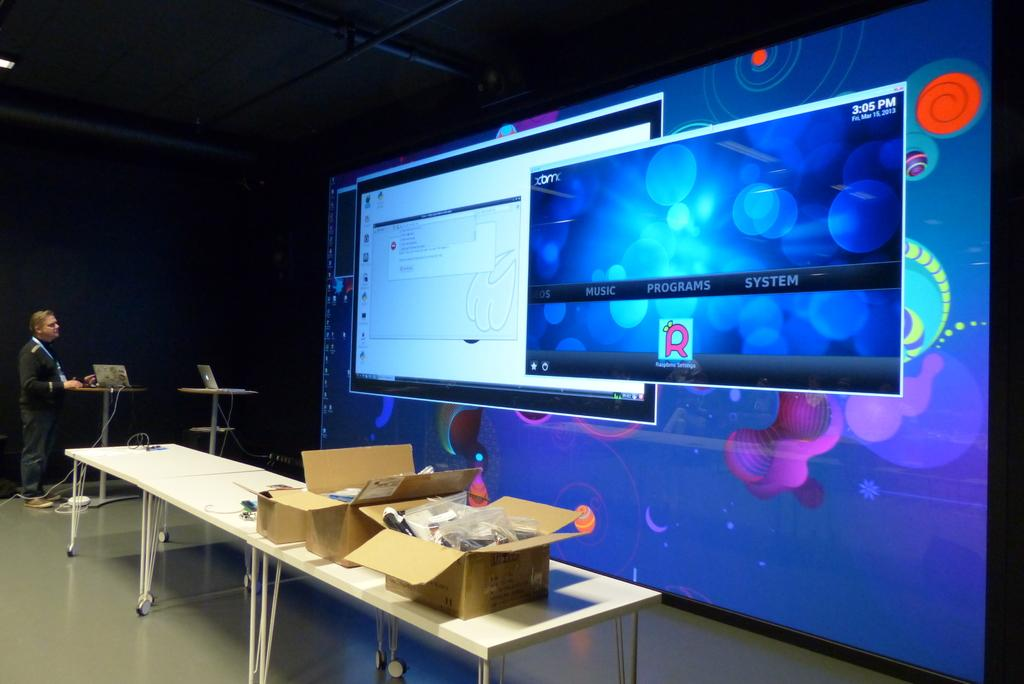<image>
Write a terse but informative summary of the picture. While one projected app has an error message, the other has loaded properly and displays, "EOS, Music, Programs, and System." 